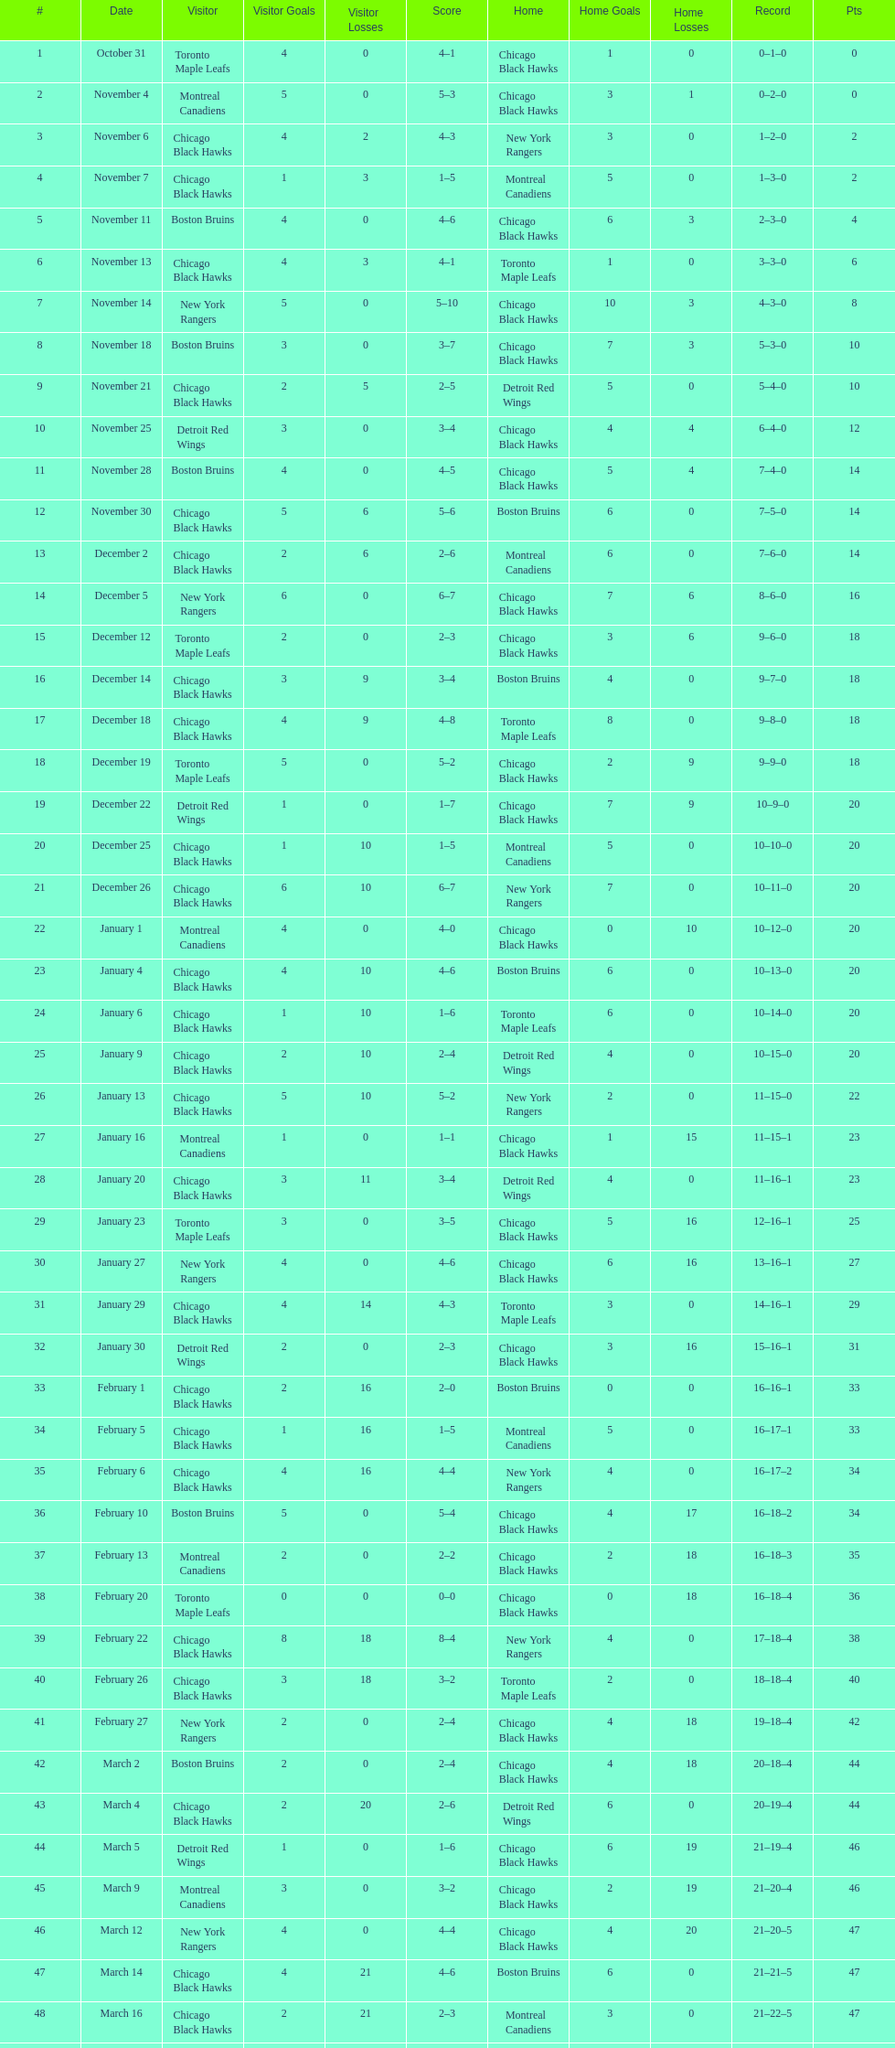What was the total amount of points scored on november 4th? 8. 